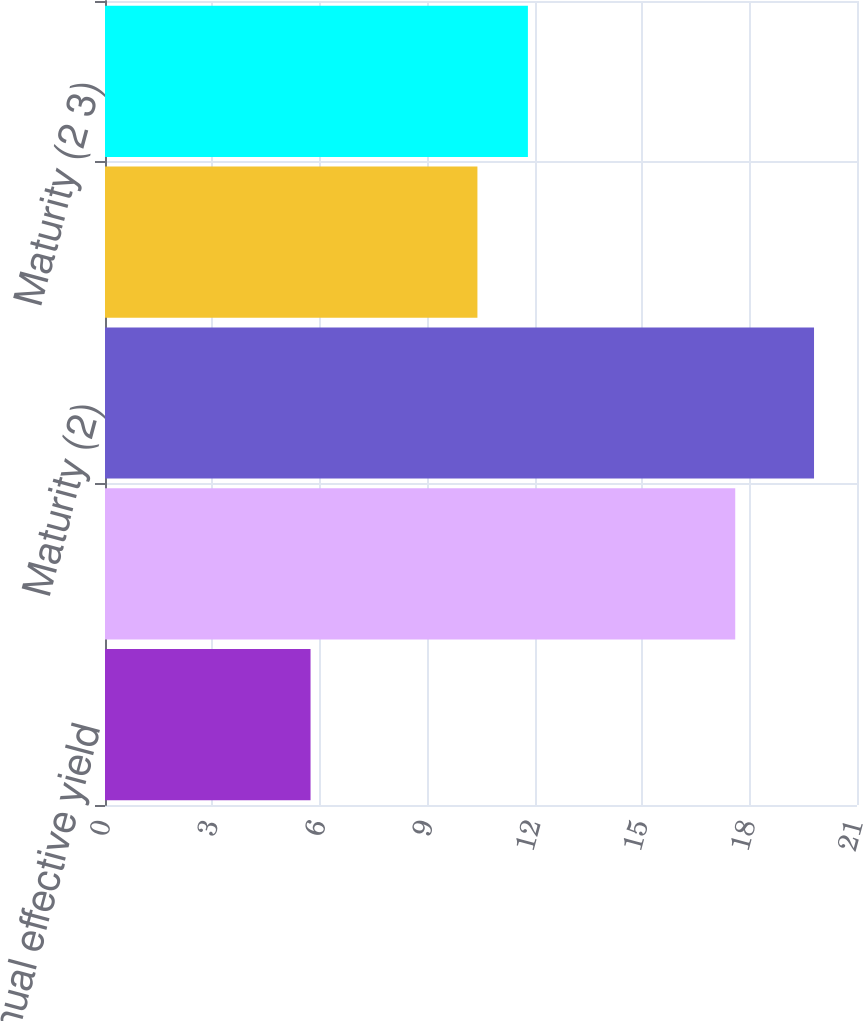Convert chart. <chart><loc_0><loc_0><loc_500><loc_500><bar_chart><fcel>Average annual effective yield<fcel>Next call (2)<fcel>Maturity (2)<fcel>Next call (2 3)<fcel>Maturity (2 3)<nl><fcel>5.74<fcel>17.6<fcel>19.8<fcel>10.4<fcel>11.81<nl></chart> 